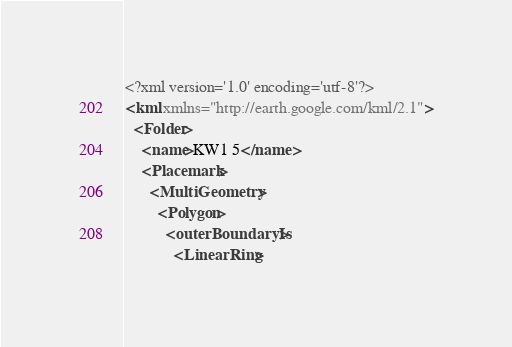Convert code to text. <code><loc_0><loc_0><loc_500><loc_500><_XML_><?xml version='1.0' encoding='utf-8'?>
<kml xmlns="http://earth.google.com/kml/2.1">
  <Folder>
    <name>KW1 5</name>
    <Placemark>
      <MultiGeometry>
        <Polygon>
          <outerBoundaryIs>
            <LinearRing></code> 